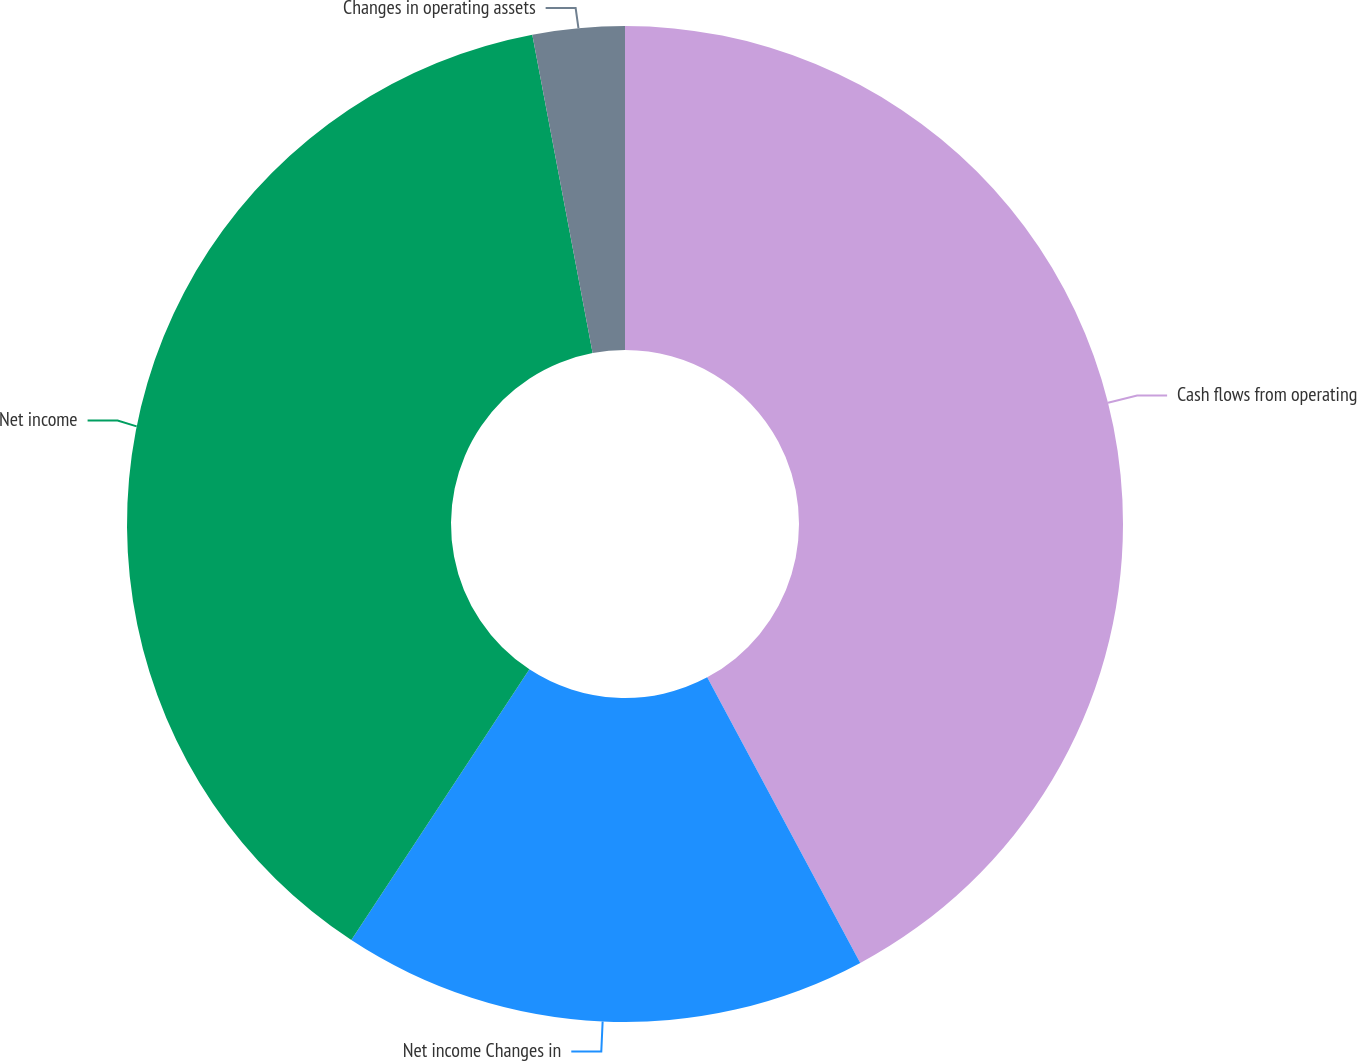Convert chart to OTSL. <chart><loc_0><loc_0><loc_500><loc_500><pie_chart><fcel>Cash flows from operating<fcel>Net income Changes in<fcel>Net income<fcel>Changes in operating assets<nl><fcel>42.17%<fcel>17.09%<fcel>37.76%<fcel>2.98%<nl></chart> 